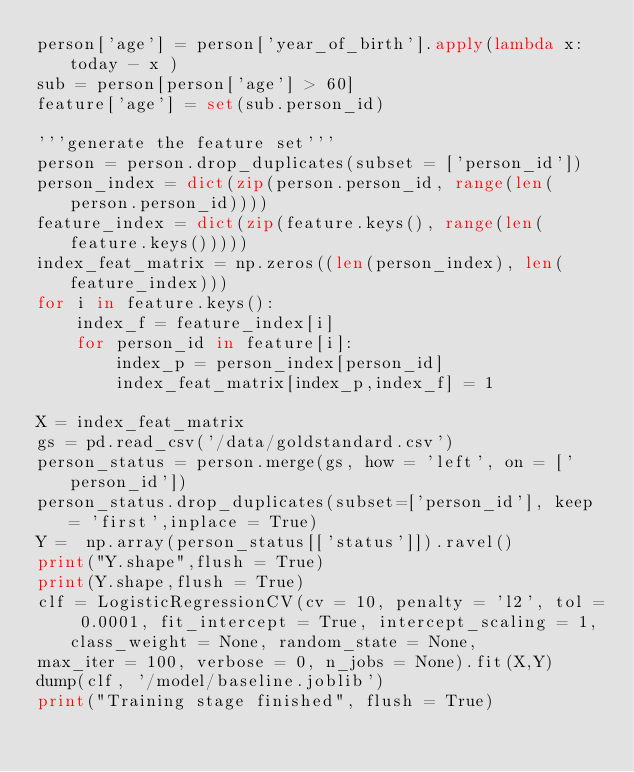Convert code to text. <code><loc_0><loc_0><loc_500><loc_500><_Python_>person['age'] = person['year_of_birth'].apply(lambda x: today - x )
sub = person[person['age'] > 60]
feature['age'] = set(sub.person_id)

'''generate the feature set'''
person = person.drop_duplicates(subset = ['person_id'])
person_index = dict(zip(person.person_id, range(len(person.person_id))))
feature_index = dict(zip(feature.keys(), range(len(feature.keys()))))
index_feat_matrix = np.zeros((len(person_index), len(feature_index)))
for i in feature.keys():
    index_f = feature_index[i]
    for person_id in feature[i]:
        index_p = person_index[person_id]
        index_feat_matrix[index_p,index_f] = 1

X = index_feat_matrix
gs = pd.read_csv('/data/goldstandard.csv')
person_status = person.merge(gs, how = 'left', on = ['person_id'])
person_status.drop_duplicates(subset=['person_id'], keep = 'first',inplace = True)
Y =  np.array(person_status[['status']]).ravel()
print("Y.shape",flush = True)
print(Y.shape,flush = True)
clf = LogisticRegressionCV(cv = 10, penalty = 'l2', tol = 0.0001, fit_intercept = True, intercept_scaling = 1, class_weight = None, random_state = None,
max_iter = 100, verbose = 0, n_jobs = None).fit(X,Y)
dump(clf, '/model/baseline.joblib')
print("Training stage finished", flush = True)
</code> 